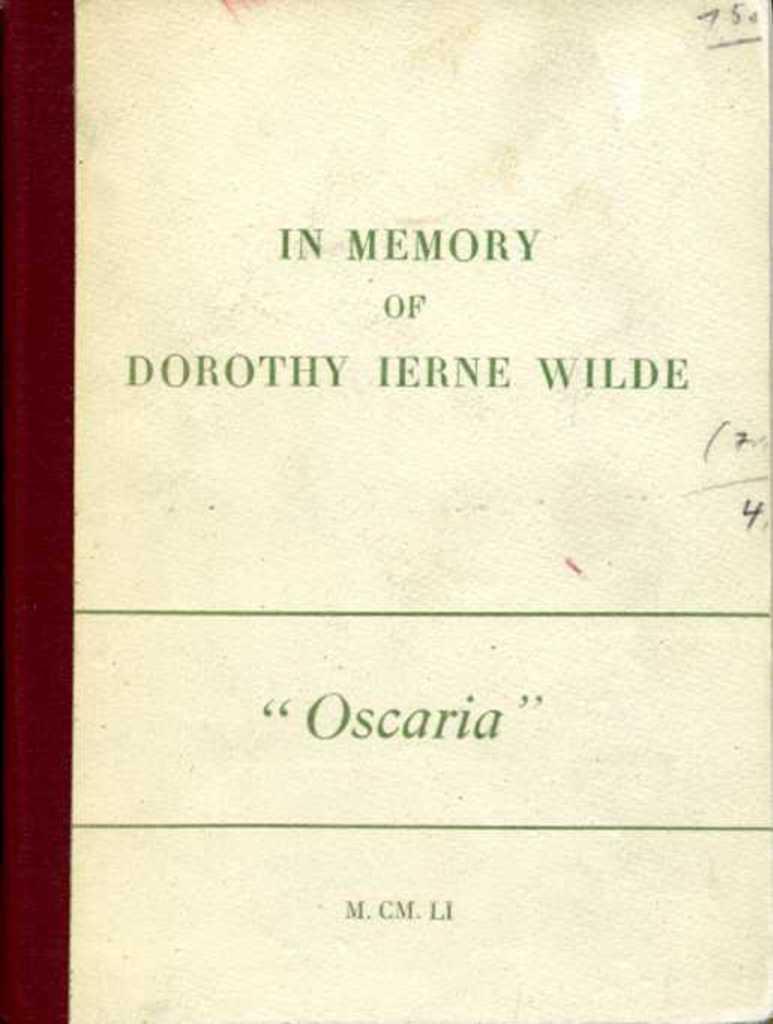Who is this document in memory of?
Offer a terse response. Dorothy ierne wilde. What is the name of the documentary?
Ensure brevity in your answer.  Oscaria. 